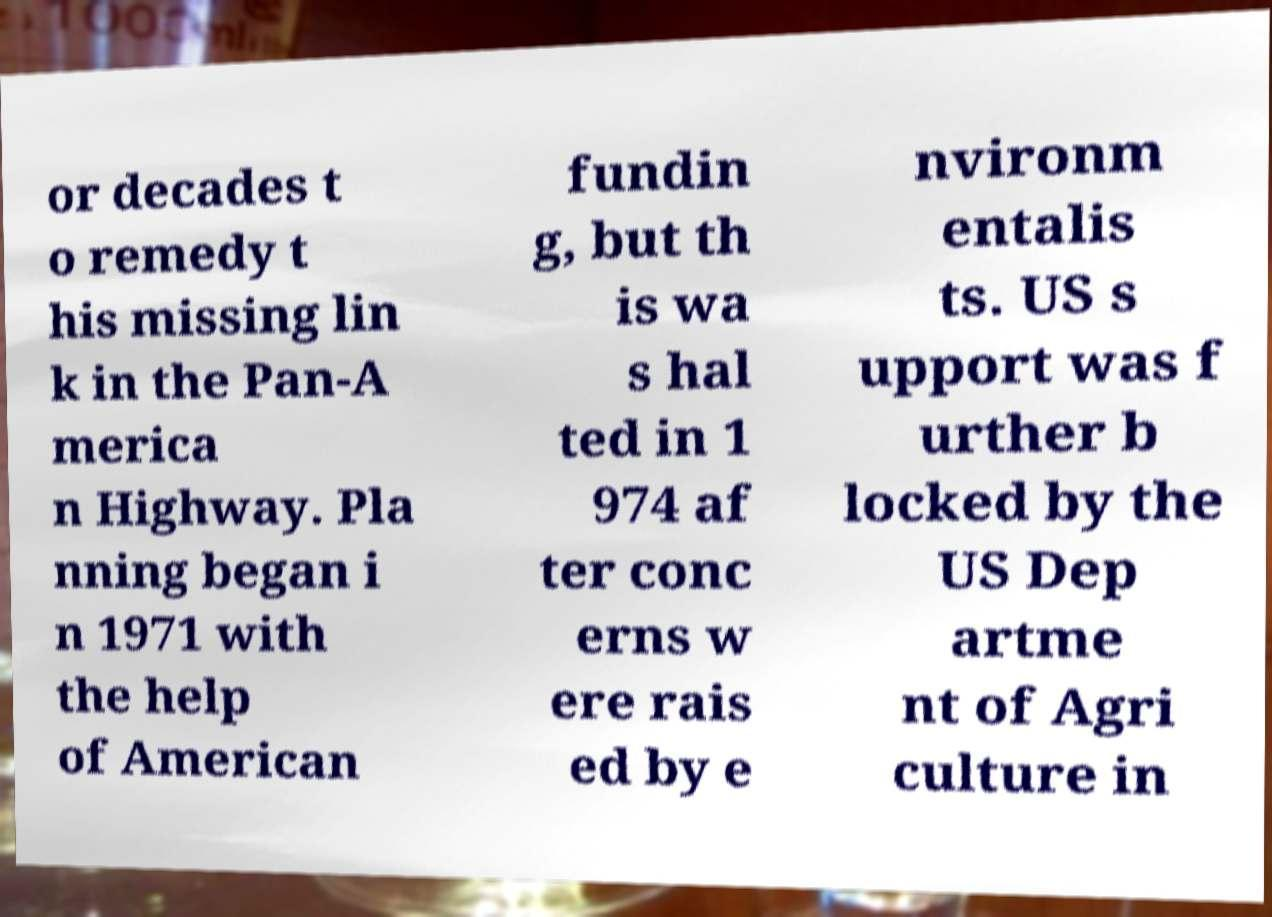Could you extract and type out the text from this image? or decades t o remedy t his missing lin k in the Pan-A merica n Highway. Pla nning began i n 1971 with the help of American fundin g, but th is wa s hal ted in 1 974 af ter conc erns w ere rais ed by e nvironm entalis ts. US s upport was f urther b locked by the US Dep artme nt of Agri culture in 